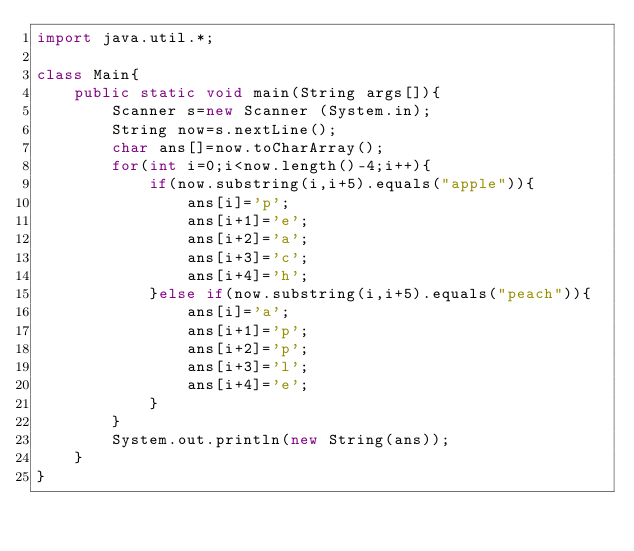Convert code to text. <code><loc_0><loc_0><loc_500><loc_500><_Java_>import java.util.*;
 
class Main{
    public static void main(String args[]){
        Scanner s=new Scanner (System.in);
        String now=s.nextLine();
        char ans[]=now.toCharArray();
        for(int i=0;i<now.length()-4;i++){
            if(now.substring(i,i+5).equals("apple")){
                ans[i]='p';
                ans[i+1]='e';
                ans[i+2]='a';
                ans[i+3]='c';
                ans[i+4]='h';
            }else if(now.substring(i,i+5).equals("peach")){
                ans[i]='a';
                ans[i+1]='p';
                ans[i+2]='p';
                ans[i+3]='l';
                ans[i+4]='e';
            }
        }
        System.out.println(new String(ans));
    }
}
</code> 